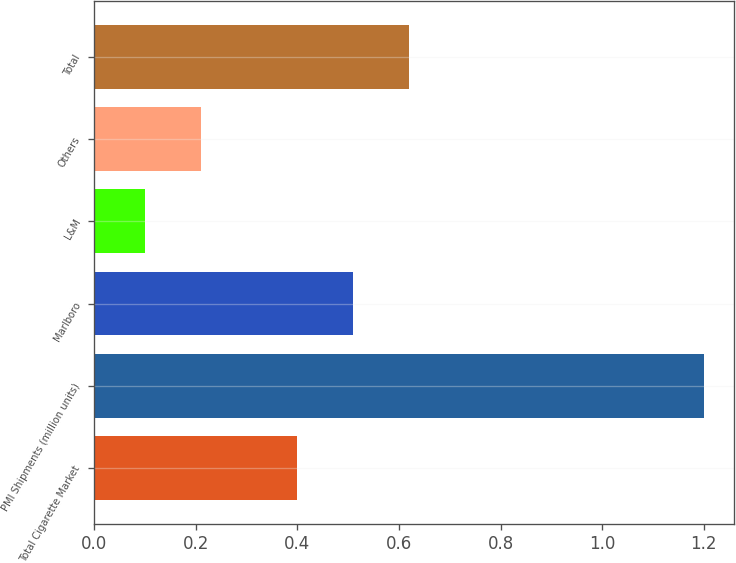Convert chart. <chart><loc_0><loc_0><loc_500><loc_500><bar_chart><fcel>Total Cigarette Market<fcel>PMI Shipments (million units)<fcel>Marlboro<fcel>L&M<fcel>Others<fcel>Total<nl><fcel>0.4<fcel>1.2<fcel>0.51<fcel>0.1<fcel>0.21<fcel>0.62<nl></chart> 